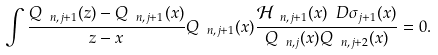Convert formula to latex. <formula><loc_0><loc_0><loc_500><loc_500>\int \frac { Q _ { \ n , j + 1 } ( z ) - Q _ { \ n , j + 1 } ( x ) } { z - x } Q _ { \ n , j + 1 } ( x ) \frac { \mathcal { H } _ { \ n , j + 1 } ( x ) \ D \sigma _ { j + 1 } ( x ) } { Q _ { \ n , j } ( x ) Q _ { \ n , j + 2 } ( x ) } = 0 .</formula> 